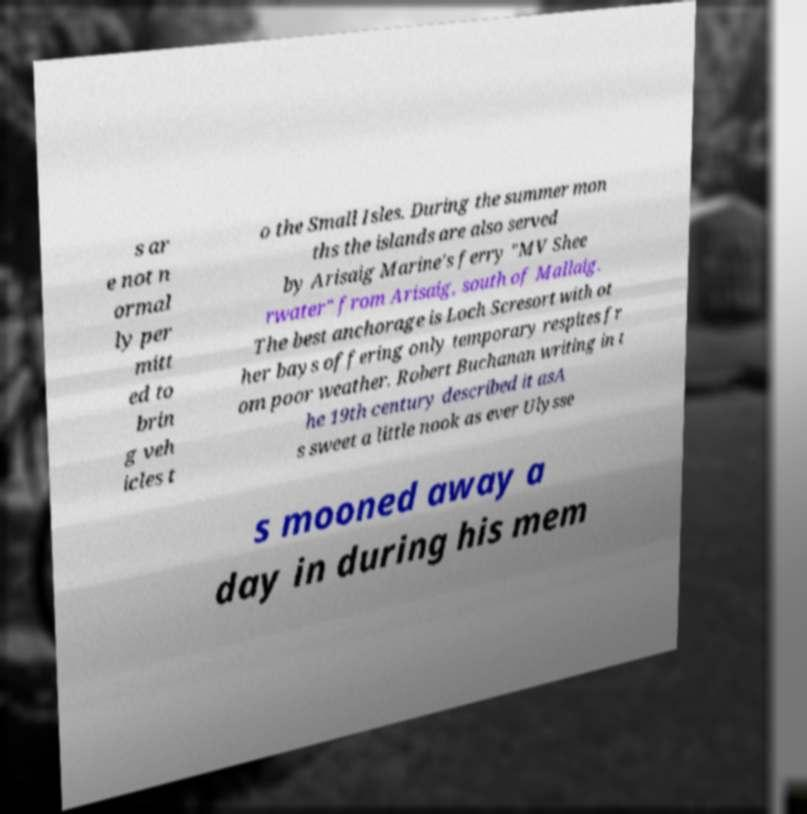What messages or text are displayed in this image? I need them in a readable, typed format. s ar e not n ormal ly per mitt ed to brin g veh icles t o the Small Isles. During the summer mon ths the islands are also served by Arisaig Marine's ferry "MV Shee rwater" from Arisaig, south of Mallaig. The best anchorage is Loch Scresort with ot her bays offering only temporary respites fr om poor weather. Robert Buchanan writing in t he 19th century described it asA s sweet a little nook as ever Ulysse s mooned away a day in during his mem 